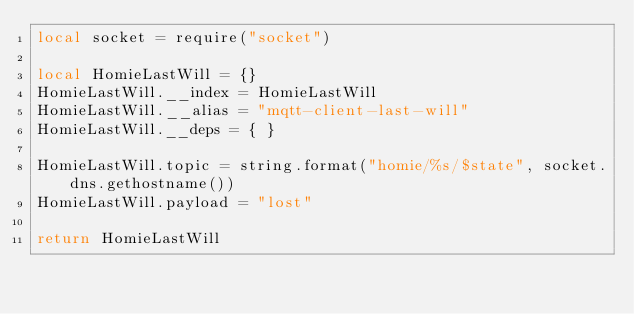Convert code to text. <code><loc_0><loc_0><loc_500><loc_500><_Lua_>local socket = require("socket")

local HomieLastWill = {}
HomieLastWill.__index = HomieLastWill
HomieLastWill.__alias = "mqtt-client-last-will"
HomieLastWill.__deps = { }

HomieLastWill.topic = string.format("homie/%s/$state", socket.dns.gethostname())
HomieLastWill.payload = "lost"

return HomieLastWill
</code> 